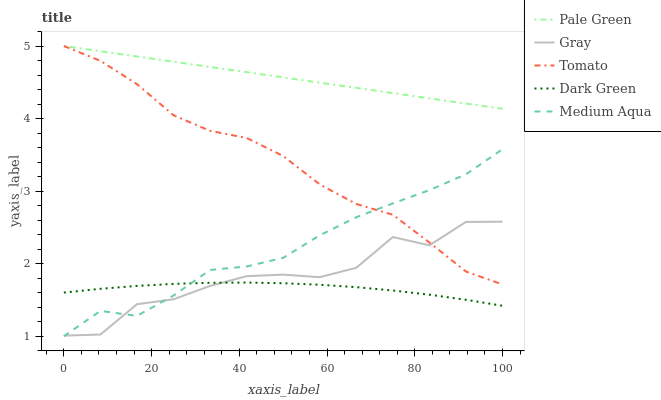Does Dark Green have the minimum area under the curve?
Answer yes or no. Yes. Does Pale Green have the maximum area under the curve?
Answer yes or no. Yes. Does Gray have the minimum area under the curve?
Answer yes or no. No. Does Gray have the maximum area under the curve?
Answer yes or no. No. Is Pale Green the smoothest?
Answer yes or no. Yes. Is Gray the roughest?
Answer yes or no. Yes. Is Gray the smoothest?
Answer yes or no. No. Is Pale Green the roughest?
Answer yes or no. No. Does Gray have the lowest value?
Answer yes or no. No. Does Pale Green have the highest value?
Answer yes or no. Yes. Does Gray have the highest value?
Answer yes or no. No. Is Dark Green less than Pale Green?
Answer yes or no. Yes. Is Pale Green greater than Dark Green?
Answer yes or no. Yes. Does Tomato intersect Gray?
Answer yes or no. Yes. Is Tomato less than Gray?
Answer yes or no. No. Is Tomato greater than Gray?
Answer yes or no. No. Does Dark Green intersect Pale Green?
Answer yes or no. No. 